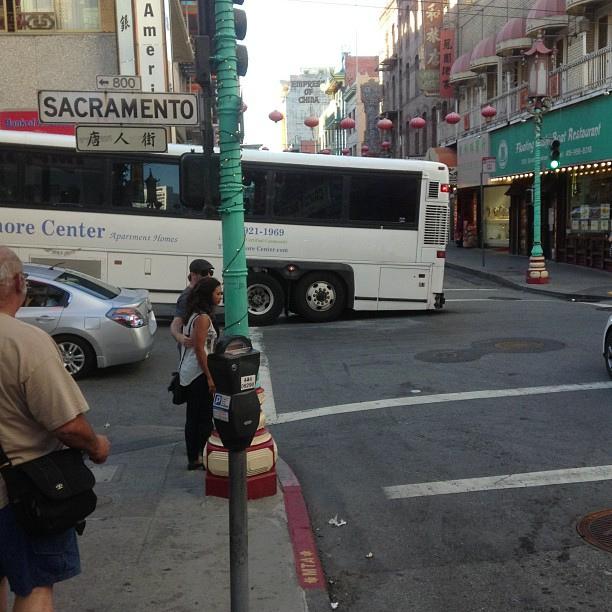Is the street name the capital of a state?
Be succinct. Yes. In what country was this picture taken?
Short answer required. Usa. How many people in the shot?
Keep it brief. 3. What is she looking at?
Answer briefly. Street. What color is the city bus?
Give a very brief answer. White. What is the lady doing?
Quick response, please. Waiting. 